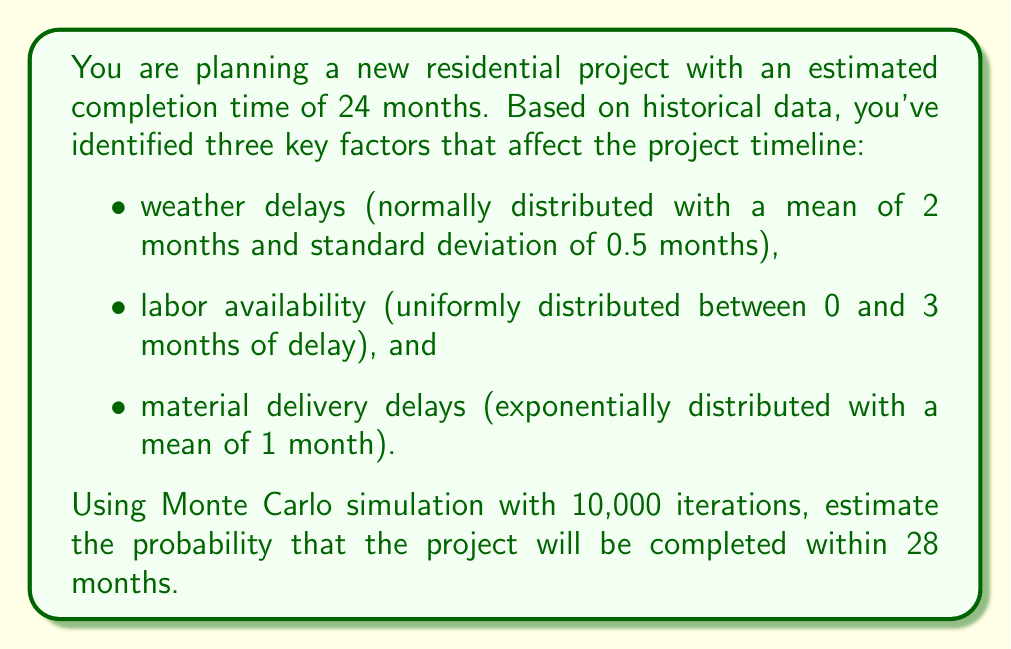Solve this math problem. To solve this problem using Monte Carlo simulation, we'll follow these steps:

1. Set up the simulation:
   - Number of iterations: 10,000
   - Target completion time: 28 months
   - Base project duration: 24 months

2. For each iteration, generate random values for the three delay factors:
   a. Weather delays: $W \sim N(\mu=2, \sigma=0.5)$
   b. Labor availability delays: $L \sim U(0, 3)$
   c. Material delivery delays: $M \sim Exp(\lambda=1)$

3. Calculate the total project duration for each iteration:
   $D_i = 24 + W_i + L_i + M_i$

4. Count the number of iterations where $D_i \leq 28$

5. Calculate the probability:
   $P(\text{completion within 28 months}) = \frac{\text{Count of } D_i \leq 28}{\text{Total iterations}}$

Here's a Python code snippet to perform the simulation:

```python
import numpy as np

np.random.seed(42)  # for reproducibility
iterations = 10000

weather_delays = np.random.normal(2, 0.5, iterations)
labor_delays = np.random.uniform(0, 3, iterations)
material_delays = np.random.exponential(1, iterations)

total_durations = 24 + weather_delays + labor_delays + material_delays
completed_within_target = np.sum(total_durations <= 28)

probability = completed_within_target / iterations
```

Running this simulation yields a probability of approximately 0.3185, or 31.85%.

This means that based on the Monte Carlo simulation with 10,000 iterations, there is about a 31.85% chance that the project will be completed within 28 months, given the specified delay distributions.
Answer: 0.3185 